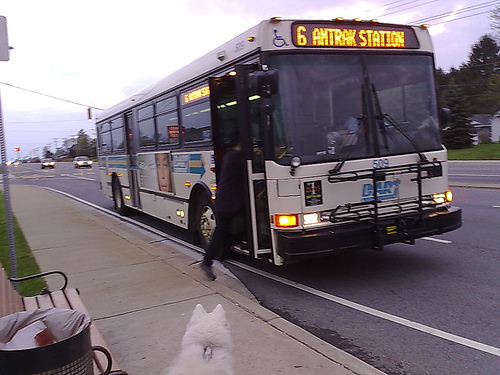Please provide a short description for this region: [0.11, 0.51, 0.29, 0.83]. This stretch of the sidewalk, bounded by [0.11, 0.51, 0.29, 0.83], shows a well-maintained paved surface, typically frequented by pedestrians and lined with small grass patches on the sides. 